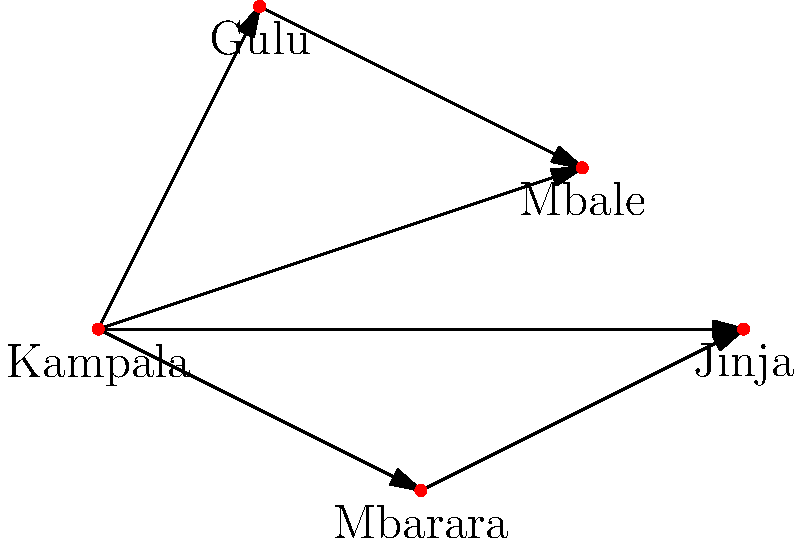Based on the topology of major cities in Uganda shown above, which city would be the most strategic location for establishing a central sexual health education outreach center to maximize connectivity and reach? To determine the most strategic location for a central sexual health education outreach center, we need to analyze the connectivity of each city:

1. Kampala:
   - Directly connected to all other cities (4 connections)
   - Central location in the network

2. Gulu:
   - Connected to Kampala and Mbale (2 connections)
   - Located in the northern part of the network

3. Mbarara:
   - Connected to Kampala and Jinja (2 connections)
   - Located in the southern part of the network

4. Mbale:
   - Connected to Kampala and Gulu (2 connections)
   - Located in the eastern part of the network

5. Jinja:
   - Connected to Kampala and Mbarara (2 connections)
   - Located in the southeastern part of the network

Kampala has the highest number of direct connections (4) and is centrally located in the network. This makes it the most strategic location for establishing a central sexual health education outreach center. From Kampala, outreach efforts can easily reach all other major cities, maximizing the effectiveness and efficiency of sexual health education initiatives across Uganda.
Answer: Kampala 